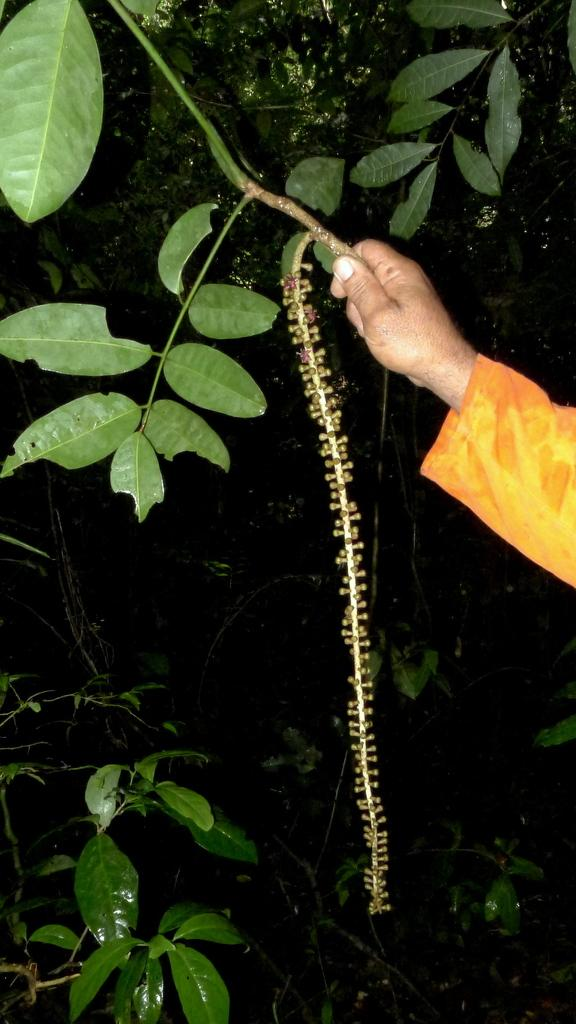What can be seen in the image? There is a person's hand in the image. What is the hand holding? The hand is holding the branch of a tree. What type of crime is being committed in the image? There is no crime being committed in the image; it simply shows a person's hand holding a tree branch. 